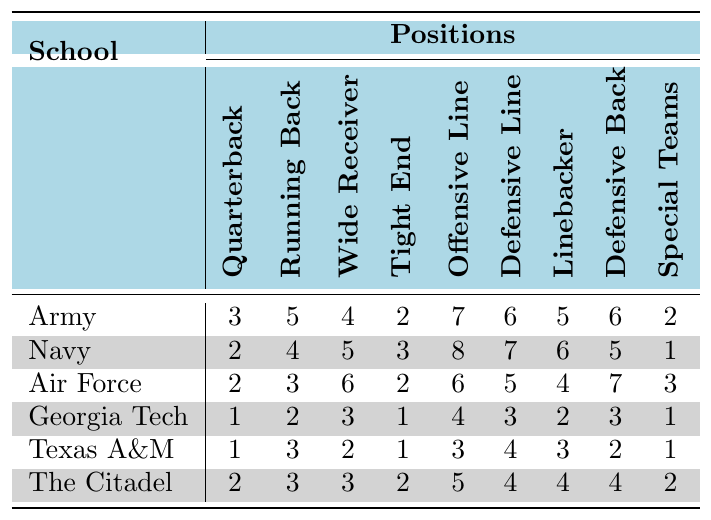What school has the highest number of scholarships allocated for running backs? By examining the column for Running Backs, Navy has the highest values with 4, while Army has 5, making Navy's figure higher than others.
Answer: Navy Which position has the least number of scholarships at Army? Looking at Army's row, the position with the fewest scholarships is Tight End with a total of 2.
Answer: Tight End What is the total number of scholarships allocated to Air Force? The total scholarships for Air Force are given directly in the Total Scholarships section as 38.
Answer: 38 How many more scholarships does Texas A&M have compared to Georgia Tech? Texas A&M has 20 scholarships, while Georgia Tech has 20. Thus, the difference is 0.
Answer: 0 Is the number of scholarships for quarterbacks at The Citadel higher than those at Army? The Citadel has 2 scholarships for Quarterbacks while Army has 3. Therefore, The Citadel’s number is not higher.
Answer: No Which position ranks the highest in terms of total scholarships across all schools? To find the position with the highest total, sum each position's scholarships per school. Both Offensive Line (33) rank the highest across all schools.
Answer: Offensive Line How many total scholarships are allocated for Defensive Backs across all schools? Summing Defensive Back scholarships: 6 (Army) + 5 (Navy) + 7 (Air Force) + 3 (Georgia Tech) + 2 (Texas A&M) + 4 (The Citadel) = 27.
Answer: 27 What percentage of the total scholarships at Navy are allocated for Special Teams? Navy has a total of 41 scholarships, and the Special Teams have 1. Calculating the percentage gives (1/41) * 100, which equals approximately 2.44%.
Answer: 2.44% Which school has the lowest allocation of scholarships for Tight Ends? By inspecting the Tight End column, Georgia Tech shows the lowest allocation with 1 scholarship.
Answer: Georgia Tech How many Linebackers are allocated scholarships at the school with the lowest total scholarships? Georgia Tech has the lowest total scholarships (20), with a Linebacker allocation of 2.
Answer: 2 What is the average number of scholarships awarded to Wide Receivers across all schools? To calculate the average for Wide Receivers: (4 + 5 + 6 + 3 + 2 + 3) = 23 scholarships in total across 6 schools, so the average is 23/6, which equals approximately 3.83.
Answer: 3.83 